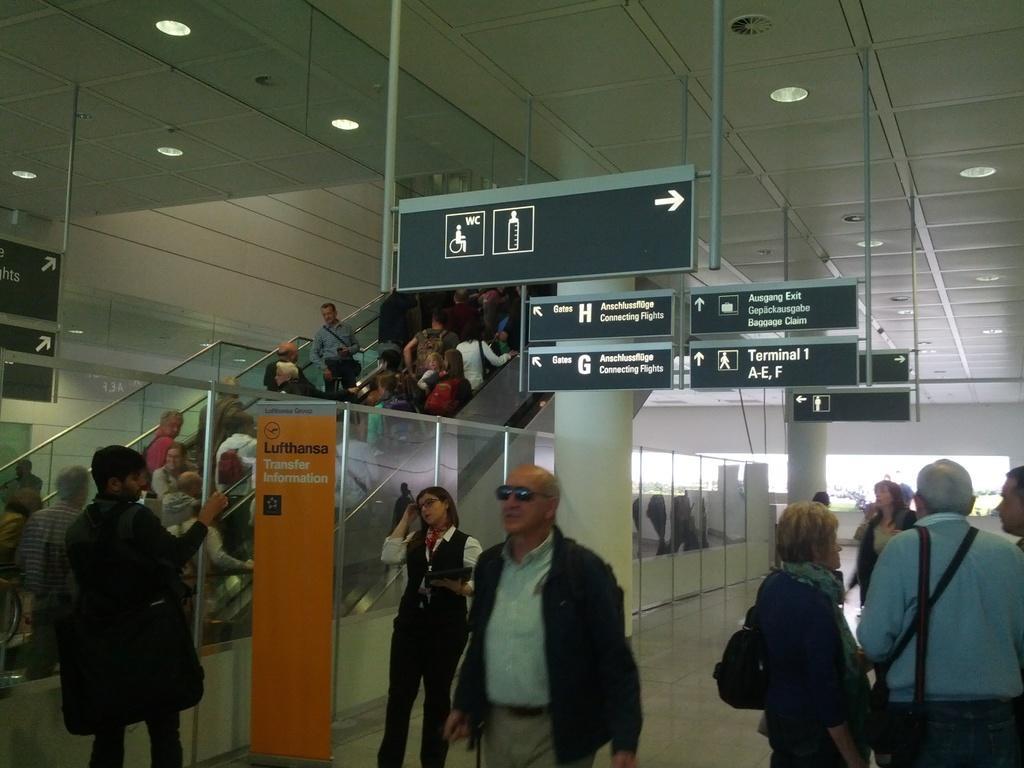In one or two sentences, can you explain what this image depicts? In this picture there is staircase on the left side of the image, on which there are people and there are other people on the right side of the image, there are sign boards in the center of the image. 